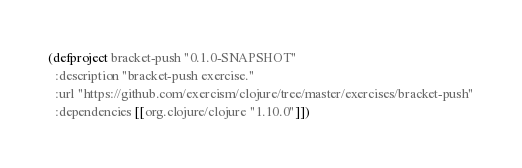Convert code to text. <code><loc_0><loc_0><loc_500><loc_500><_Clojure_>(defproject bracket-push "0.1.0-SNAPSHOT"
  :description "bracket-push exercise."
  :url "https://github.com/exercism/clojure/tree/master/exercises/bracket-push"
  :dependencies [[org.clojure/clojure "1.10.0"]])
</code> 